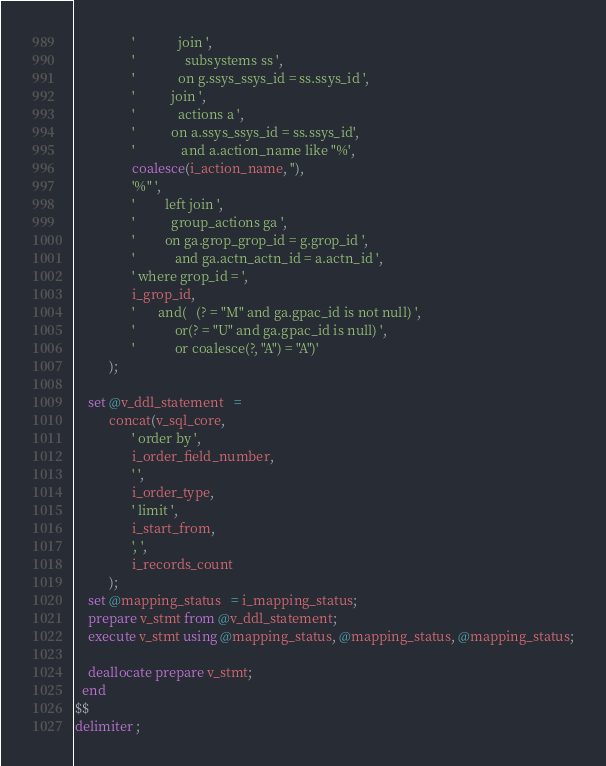<code> <loc_0><loc_0><loc_500><loc_500><_SQL_>                 '             join ',
                 '               subsystems ss ',
                 '             on g.ssys_ssys_id = ss.ssys_id ',
                 '           join ',
                 '             actions a ',
                 '           on a.ssys_ssys_id = ss.ssys_id',
                 '              and a.action_name like "%',
                 coalesce(i_action_name, ''),
                 '%" ',
                 '         left join ',
                 '           group_actions ga ',
                 '         on ga.grop_grop_id = g.grop_id ',
                 '            and ga.actn_actn_id = a.actn_id ',
                 ' where grop_id = ',
                 i_grop_id,
                 '       and(   (? = "M" and ga.gpac_id is not null) ',
                 '            or(? = "U" and ga.gpac_id is null) ',
                 '            or coalesce(?, "A") = "A")'
          );

    set @v_ddl_statement   =
          concat(v_sql_core,
                 ' order by ',
                 i_order_field_number,
                 ' ',
                 i_order_type,
                 ' limit ',
                 i_start_from,
                 ', ',
                 i_records_count
          );
    set @mapping_status   = i_mapping_status;
    prepare v_stmt from @v_ddl_statement;
    execute v_stmt using @mapping_status, @mapping_status, @mapping_status;

    deallocate prepare v_stmt;
  end
$$
delimiter ;</code> 